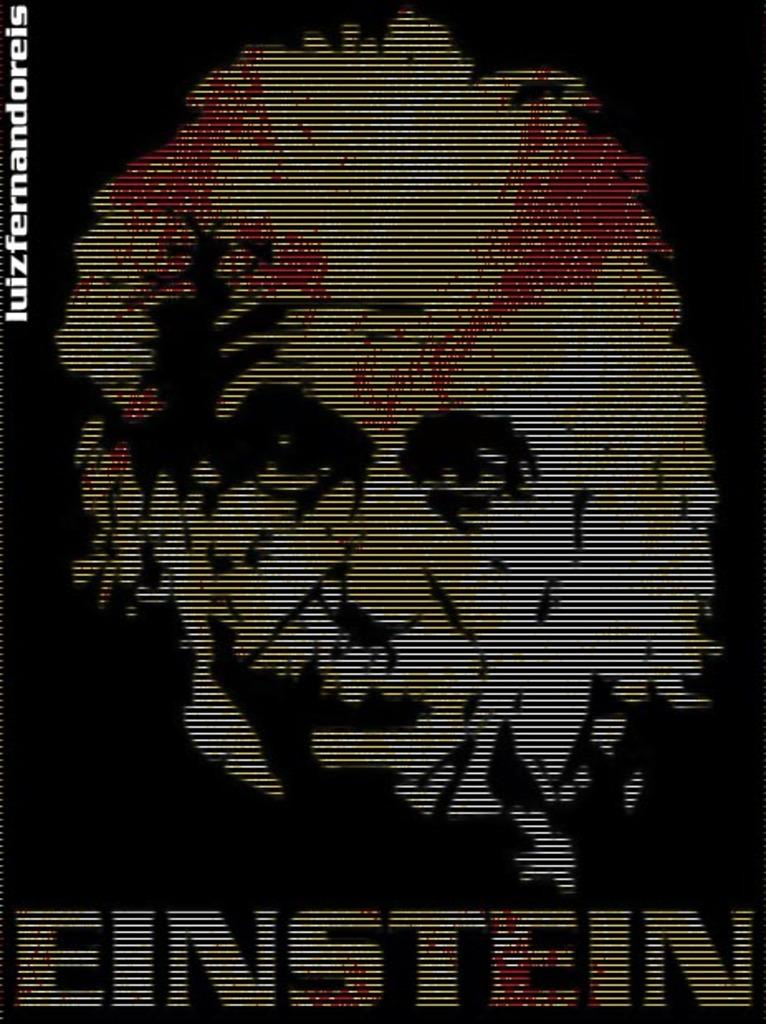<image>
Share a concise interpretation of the image provided. A black poster with the face of Einstein. 